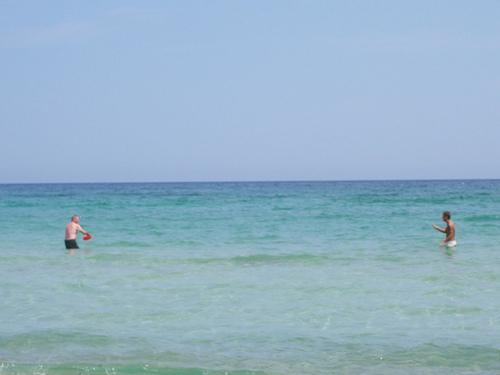Why does the man in white have his arm out?

Choices:
A) to wave
B) to catch
C) for balance
D) to reach to catch 